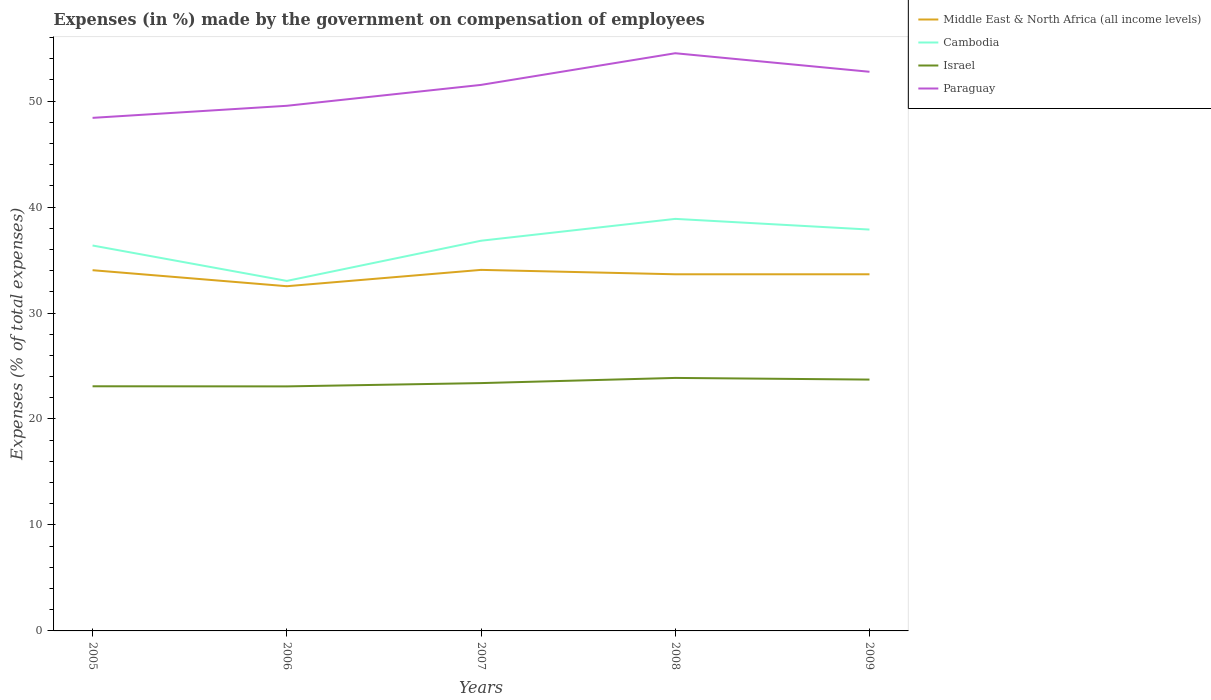Does the line corresponding to Israel intersect with the line corresponding to Middle East & North Africa (all income levels)?
Provide a short and direct response. No. Across all years, what is the maximum percentage of expenses made by the government on compensation of employees in Israel?
Offer a terse response. 23.08. In which year was the percentage of expenses made by the government on compensation of employees in Paraguay maximum?
Offer a very short reply. 2005. What is the total percentage of expenses made by the government on compensation of employees in Israel in the graph?
Offer a terse response. -0.49. What is the difference between the highest and the second highest percentage of expenses made by the government on compensation of employees in Middle East & North Africa (all income levels)?
Your answer should be compact. 1.54. What is the difference between the highest and the lowest percentage of expenses made by the government on compensation of employees in Middle East & North Africa (all income levels)?
Your answer should be very brief. 4. Is the percentage of expenses made by the government on compensation of employees in Cambodia strictly greater than the percentage of expenses made by the government on compensation of employees in Israel over the years?
Make the answer very short. No. How many lines are there?
Make the answer very short. 4. How many years are there in the graph?
Provide a short and direct response. 5. Are the values on the major ticks of Y-axis written in scientific E-notation?
Ensure brevity in your answer.  No. Does the graph contain grids?
Your answer should be very brief. No. Where does the legend appear in the graph?
Offer a terse response. Top right. How are the legend labels stacked?
Make the answer very short. Vertical. What is the title of the graph?
Offer a terse response. Expenses (in %) made by the government on compensation of employees. Does "Cote d'Ivoire" appear as one of the legend labels in the graph?
Provide a succinct answer. No. What is the label or title of the Y-axis?
Your answer should be very brief. Expenses (% of total expenses). What is the Expenses (% of total expenses) in Middle East & North Africa (all income levels) in 2005?
Give a very brief answer. 34.04. What is the Expenses (% of total expenses) in Cambodia in 2005?
Provide a short and direct response. 36.37. What is the Expenses (% of total expenses) of Israel in 2005?
Provide a succinct answer. 23.09. What is the Expenses (% of total expenses) in Paraguay in 2005?
Your answer should be compact. 48.42. What is the Expenses (% of total expenses) of Middle East & North Africa (all income levels) in 2006?
Provide a succinct answer. 32.53. What is the Expenses (% of total expenses) in Cambodia in 2006?
Your answer should be very brief. 33.03. What is the Expenses (% of total expenses) in Israel in 2006?
Give a very brief answer. 23.08. What is the Expenses (% of total expenses) of Paraguay in 2006?
Provide a succinct answer. 49.56. What is the Expenses (% of total expenses) of Middle East & North Africa (all income levels) in 2007?
Provide a short and direct response. 34.07. What is the Expenses (% of total expenses) of Cambodia in 2007?
Offer a very short reply. 36.82. What is the Expenses (% of total expenses) of Israel in 2007?
Give a very brief answer. 23.39. What is the Expenses (% of total expenses) in Paraguay in 2007?
Your response must be concise. 51.53. What is the Expenses (% of total expenses) of Middle East & North Africa (all income levels) in 2008?
Offer a very short reply. 33.65. What is the Expenses (% of total expenses) of Cambodia in 2008?
Provide a succinct answer. 38.88. What is the Expenses (% of total expenses) of Israel in 2008?
Ensure brevity in your answer.  23.87. What is the Expenses (% of total expenses) in Paraguay in 2008?
Your response must be concise. 54.52. What is the Expenses (% of total expenses) of Middle East & North Africa (all income levels) in 2009?
Offer a very short reply. 33.66. What is the Expenses (% of total expenses) in Cambodia in 2009?
Offer a terse response. 37.88. What is the Expenses (% of total expenses) in Israel in 2009?
Keep it short and to the point. 23.72. What is the Expenses (% of total expenses) of Paraguay in 2009?
Offer a very short reply. 52.77. Across all years, what is the maximum Expenses (% of total expenses) in Middle East & North Africa (all income levels)?
Make the answer very short. 34.07. Across all years, what is the maximum Expenses (% of total expenses) in Cambodia?
Ensure brevity in your answer.  38.88. Across all years, what is the maximum Expenses (% of total expenses) in Israel?
Offer a very short reply. 23.87. Across all years, what is the maximum Expenses (% of total expenses) in Paraguay?
Ensure brevity in your answer.  54.52. Across all years, what is the minimum Expenses (% of total expenses) of Middle East & North Africa (all income levels)?
Your answer should be very brief. 32.53. Across all years, what is the minimum Expenses (% of total expenses) in Cambodia?
Offer a very short reply. 33.03. Across all years, what is the minimum Expenses (% of total expenses) in Israel?
Your answer should be very brief. 23.08. Across all years, what is the minimum Expenses (% of total expenses) in Paraguay?
Give a very brief answer. 48.42. What is the total Expenses (% of total expenses) of Middle East & North Africa (all income levels) in the graph?
Your answer should be very brief. 167.95. What is the total Expenses (% of total expenses) in Cambodia in the graph?
Provide a succinct answer. 182.98. What is the total Expenses (% of total expenses) of Israel in the graph?
Your answer should be compact. 117.14. What is the total Expenses (% of total expenses) in Paraguay in the graph?
Your answer should be compact. 256.78. What is the difference between the Expenses (% of total expenses) in Middle East & North Africa (all income levels) in 2005 and that in 2006?
Make the answer very short. 1.51. What is the difference between the Expenses (% of total expenses) in Cambodia in 2005 and that in 2006?
Offer a very short reply. 3.34. What is the difference between the Expenses (% of total expenses) of Israel in 2005 and that in 2006?
Your answer should be compact. 0.01. What is the difference between the Expenses (% of total expenses) of Paraguay in 2005 and that in 2006?
Your response must be concise. -1.14. What is the difference between the Expenses (% of total expenses) of Middle East & North Africa (all income levels) in 2005 and that in 2007?
Offer a terse response. -0.03. What is the difference between the Expenses (% of total expenses) of Cambodia in 2005 and that in 2007?
Provide a succinct answer. -0.45. What is the difference between the Expenses (% of total expenses) in Israel in 2005 and that in 2007?
Provide a succinct answer. -0.3. What is the difference between the Expenses (% of total expenses) of Paraguay in 2005 and that in 2007?
Provide a succinct answer. -3.11. What is the difference between the Expenses (% of total expenses) of Middle East & North Africa (all income levels) in 2005 and that in 2008?
Keep it short and to the point. 0.39. What is the difference between the Expenses (% of total expenses) in Cambodia in 2005 and that in 2008?
Make the answer very short. -2.51. What is the difference between the Expenses (% of total expenses) of Israel in 2005 and that in 2008?
Your answer should be very brief. -0.79. What is the difference between the Expenses (% of total expenses) in Paraguay in 2005 and that in 2008?
Offer a terse response. -6.1. What is the difference between the Expenses (% of total expenses) of Middle East & North Africa (all income levels) in 2005 and that in 2009?
Your response must be concise. 0.39. What is the difference between the Expenses (% of total expenses) in Cambodia in 2005 and that in 2009?
Make the answer very short. -1.5. What is the difference between the Expenses (% of total expenses) in Israel in 2005 and that in 2009?
Keep it short and to the point. -0.63. What is the difference between the Expenses (% of total expenses) of Paraguay in 2005 and that in 2009?
Your answer should be compact. -4.35. What is the difference between the Expenses (% of total expenses) in Middle East & North Africa (all income levels) in 2006 and that in 2007?
Keep it short and to the point. -1.54. What is the difference between the Expenses (% of total expenses) in Cambodia in 2006 and that in 2007?
Your answer should be very brief. -3.79. What is the difference between the Expenses (% of total expenses) of Israel in 2006 and that in 2007?
Offer a terse response. -0.31. What is the difference between the Expenses (% of total expenses) in Paraguay in 2006 and that in 2007?
Your answer should be compact. -1.97. What is the difference between the Expenses (% of total expenses) of Middle East & North Africa (all income levels) in 2006 and that in 2008?
Offer a terse response. -1.13. What is the difference between the Expenses (% of total expenses) in Cambodia in 2006 and that in 2008?
Provide a succinct answer. -5.85. What is the difference between the Expenses (% of total expenses) in Israel in 2006 and that in 2008?
Make the answer very short. -0.8. What is the difference between the Expenses (% of total expenses) of Paraguay in 2006 and that in 2008?
Keep it short and to the point. -4.96. What is the difference between the Expenses (% of total expenses) in Middle East & North Africa (all income levels) in 2006 and that in 2009?
Offer a terse response. -1.13. What is the difference between the Expenses (% of total expenses) in Cambodia in 2006 and that in 2009?
Provide a succinct answer. -4.85. What is the difference between the Expenses (% of total expenses) in Israel in 2006 and that in 2009?
Ensure brevity in your answer.  -0.64. What is the difference between the Expenses (% of total expenses) in Paraguay in 2006 and that in 2009?
Provide a succinct answer. -3.21. What is the difference between the Expenses (% of total expenses) in Middle East & North Africa (all income levels) in 2007 and that in 2008?
Provide a succinct answer. 0.42. What is the difference between the Expenses (% of total expenses) of Cambodia in 2007 and that in 2008?
Give a very brief answer. -2.06. What is the difference between the Expenses (% of total expenses) in Israel in 2007 and that in 2008?
Provide a succinct answer. -0.49. What is the difference between the Expenses (% of total expenses) of Paraguay in 2007 and that in 2008?
Give a very brief answer. -2.99. What is the difference between the Expenses (% of total expenses) of Middle East & North Africa (all income levels) in 2007 and that in 2009?
Your answer should be very brief. 0.42. What is the difference between the Expenses (% of total expenses) of Cambodia in 2007 and that in 2009?
Offer a very short reply. -1.05. What is the difference between the Expenses (% of total expenses) of Israel in 2007 and that in 2009?
Your answer should be compact. -0.33. What is the difference between the Expenses (% of total expenses) of Paraguay in 2007 and that in 2009?
Ensure brevity in your answer.  -1.24. What is the difference between the Expenses (% of total expenses) in Middle East & North Africa (all income levels) in 2008 and that in 2009?
Your answer should be compact. -0. What is the difference between the Expenses (% of total expenses) of Cambodia in 2008 and that in 2009?
Your answer should be compact. 1.01. What is the difference between the Expenses (% of total expenses) of Israel in 2008 and that in 2009?
Keep it short and to the point. 0.16. What is the difference between the Expenses (% of total expenses) in Middle East & North Africa (all income levels) in 2005 and the Expenses (% of total expenses) in Cambodia in 2006?
Ensure brevity in your answer.  1.01. What is the difference between the Expenses (% of total expenses) of Middle East & North Africa (all income levels) in 2005 and the Expenses (% of total expenses) of Israel in 2006?
Your response must be concise. 10.96. What is the difference between the Expenses (% of total expenses) of Middle East & North Africa (all income levels) in 2005 and the Expenses (% of total expenses) of Paraguay in 2006?
Offer a terse response. -15.52. What is the difference between the Expenses (% of total expenses) in Cambodia in 2005 and the Expenses (% of total expenses) in Israel in 2006?
Make the answer very short. 13.29. What is the difference between the Expenses (% of total expenses) of Cambodia in 2005 and the Expenses (% of total expenses) of Paraguay in 2006?
Offer a terse response. -13.18. What is the difference between the Expenses (% of total expenses) in Israel in 2005 and the Expenses (% of total expenses) in Paraguay in 2006?
Your answer should be compact. -26.47. What is the difference between the Expenses (% of total expenses) in Middle East & North Africa (all income levels) in 2005 and the Expenses (% of total expenses) in Cambodia in 2007?
Give a very brief answer. -2.78. What is the difference between the Expenses (% of total expenses) in Middle East & North Africa (all income levels) in 2005 and the Expenses (% of total expenses) in Israel in 2007?
Offer a very short reply. 10.65. What is the difference between the Expenses (% of total expenses) of Middle East & North Africa (all income levels) in 2005 and the Expenses (% of total expenses) of Paraguay in 2007?
Give a very brief answer. -17.49. What is the difference between the Expenses (% of total expenses) in Cambodia in 2005 and the Expenses (% of total expenses) in Israel in 2007?
Ensure brevity in your answer.  12.98. What is the difference between the Expenses (% of total expenses) of Cambodia in 2005 and the Expenses (% of total expenses) of Paraguay in 2007?
Your answer should be very brief. -15.16. What is the difference between the Expenses (% of total expenses) in Israel in 2005 and the Expenses (% of total expenses) in Paraguay in 2007?
Keep it short and to the point. -28.44. What is the difference between the Expenses (% of total expenses) in Middle East & North Africa (all income levels) in 2005 and the Expenses (% of total expenses) in Cambodia in 2008?
Ensure brevity in your answer.  -4.84. What is the difference between the Expenses (% of total expenses) of Middle East & North Africa (all income levels) in 2005 and the Expenses (% of total expenses) of Israel in 2008?
Ensure brevity in your answer.  10.17. What is the difference between the Expenses (% of total expenses) in Middle East & North Africa (all income levels) in 2005 and the Expenses (% of total expenses) in Paraguay in 2008?
Your answer should be compact. -20.48. What is the difference between the Expenses (% of total expenses) in Cambodia in 2005 and the Expenses (% of total expenses) in Israel in 2008?
Ensure brevity in your answer.  12.5. What is the difference between the Expenses (% of total expenses) of Cambodia in 2005 and the Expenses (% of total expenses) of Paraguay in 2008?
Offer a very short reply. -18.14. What is the difference between the Expenses (% of total expenses) in Israel in 2005 and the Expenses (% of total expenses) in Paraguay in 2008?
Provide a succinct answer. -31.43. What is the difference between the Expenses (% of total expenses) of Middle East & North Africa (all income levels) in 2005 and the Expenses (% of total expenses) of Cambodia in 2009?
Your response must be concise. -3.84. What is the difference between the Expenses (% of total expenses) of Middle East & North Africa (all income levels) in 2005 and the Expenses (% of total expenses) of Israel in 2009?
Your answer should be compact. 10.32. What is the difference between the Expenses (% of total expenses) of Middle East & North Africa (all income levels) in 2005 and the Expenses (% of total expenses) of Paraguay in 2009?
Make the answer very short. -18.72. What is the difference between the Expenses (% of total expenses) in Cambodia in 2005 and the Expenses (% of total expenses) in Israel in 2009?
Offer a terse response. 12.65. What is the difference between the Expenses (% of total expenses) of Cambodia in 2005 and the Expenses (% of total expenses) of Paraguay in 2009?
Offer a very short reply. -16.39. What is the difference between the Expenses (% of total expenses) in Israel in 2005 and the Expenses (% of total expenses) in Paraguay in 2009?
Your answer should be compact. -29.68. What is the difference between the Expenses (% of total expenses) in Middle East & North Africa (all income levels) in 2006 and the Expenses (% of total expenses) in Cambodia in 2007?
Offer a terse response. -4.29. What is the difference between the Expenses (% of total expenses) in Middle East & North Africa (all income levels) in 2006 and the Expenses (% of total expenses) in Israel in 2007?
Your answer should be very brief. 9.14. What is the difference between the Expenses (% of total expenses) of Middle East & North Africa (all income levels) in 2006 and the Expenses (% of total expenses) of Paraguay in 2007?
Your answer should be very brief. -19. What is the difference between the Expenses (% of total expenses) of Cambodia in 2006 and the Expenses (% of total expenses) of Israel in 2007?
Provide a short and direct response. 9.64. What is the difference between the Expenses (% of total expenses) of Cambodia in 2006 and the Expenses (% of total expenses) of Paraguay in 2007?
Your answer should be very brief. -18.5. What is the difference between the Expenses (% of total expenses) in Israel in 2006 and the Expenses (% of total expenses) in Paraguay in 2007?
Make the answer very short. -28.45. What is the difference between the Expenses (% of total expenses) of Middle East & North Africa (all income levels) in 2006 and the Expenses (% of total expenses) of Cambodia in 2008?
Your answer should be very brief. -6.35. What is the difference between the Expenses (% of total expenses) of Middle East & North Africa (all income levels) in 2006 and the Expenses (% of total expenses) of Israel in 2008?
Offer a very short reply. 8.65. What is the difference between the Expenses (% of total expenses) in Middle East & North Africa (all income levels) in 2006 and the Expenses (% of total expenses) in Paraguay in 2008?
Make the answer very short. -21.99. What is the difference between the Expenses (% of total expenses) of Cambodia in 2006 and the Expenses (% of total expenses) of Israel in 2008?
Offer a very short reply. 9.15. What is the difference between the Expenses (% of total expenses) of Cambodia in 2006 and the Expenses (% of total expenses) of Paraguay in 2008?
Make the answer very short. -21.49. What is the difference between the Expenses (% of total expenses) in Israel in 2006 and the Expenses (% of total expenses) in Paraguay in 2008?
Your answer should be compact. -31.44. What is the difference between the Expenses (% of total expenses) of Middle East & North Africa (all income levels) in 2006 and the Expenses (% of total expenses) of Cambodia in 2009?
Your answer should be very brief. -5.35. What is the difference between the Expenses (% of total expenses) in Middle East & North Africa (all income levels) in 2006 and the Expenses (% of total expenses) in Israel in 2009?
Make the answer very short. 8.81. What is the difference between the Expenses (% of total expenses) in Middle East & North Africa (all income levels) in 2006 and the Expenses (% of total expenses) in Paraguay in 2009?
Provide a short and direct response. -20.24. What is the difference between the Expenses (% of total expenses) of Cambodia in 2006 and the Expenses (% of total expenses) of Israel in 2009?
Provide a succinct answer. 9.31. What is the difference between the Expenses (% of total expenses) in Cambodia in 2006 and the Expenses (% of total expenses) in Paraguay in 2009?
Ensure brevity in your answer.  -19.74. What is the difference between the Expenses (% of total expenses) of Israel in 2006 and the Expenses (% of total expenses) of Paraguay in 2009?
Your answer should be compact. -29.69. What is the difference between the Expenses (% of total expenses) of Middle East & North Africa (all income levels) in 2007 and the Expenses (% of total expenses) of Cambodia in 2008?
Give a very brief answer. -4.81. What is the difference between the Expenses (% of total expenses) of Middle East & North Africa (all income levels) in 2007 and the Expenses (% of total expenses) of Israel in 2008?
Your response must be concise. 10.2. What is the difference between the Expenses (% of total expenses) of Middle East & North Africa (all income levels) in 2007 and the Expenses (% of total expenses) of Paraguay in 2008?
Offer a terse response. -20.44. What is the difference between the Expenses (% of total expenses) of Cambodia in 2007 and the Expenses (% of total expenses) of Israel in 2008?
Offer a very short reply. 12.95. What is the difference between the Expenses (% of total expenses) in Cambodia in 2007 and the Expenses (% of total expenses) in Paraguay in 2008?
Make the answer very short. -17.69. What is the difference between the Expenses (% of total expenses) in Israel in 2007 and the Expenses (% of total expenses) in Paraguay in 2008?
Make the answer very short. -31.13. What is the difference between the Expenses (% of total expenses) of Middle East & North Africa (all income levels) in 2007 and the Expenses (% of total expenses) of Cambodia in 2009?
Give a very brief answer. -3.8. What is the difference between the Expenses (% of total expenses) of Middle East & North Africa (all income levels) in 2007 and the Expenses (% of total expenses) of Israel in 2009?
Make the answer very short. 10.35. What is the difference between the Expenses (% of total expenses) of Middle East & North Africa (all income levels) in 2007 and the Expenses (% of total expenses) of Paraguay in 2009?
Your answer should be compact. -18.69. What is the difference between the Expenses (% of total expenses) in Cambodia in 2007 and the Expenses (% of total expenses) in Israel in 2009?
Offer a terse response. 13.1. What is the difference between the Expenses (% of total expenses) of Cambodia in 2007 and the Expenses (% of total expenses) of Paraguay in 2009?
Your response must be concise. -15.94. What is the difference between the Expenses (% of total expenses) of Israel in 2007 and the Expenses (% of total expenses) of Paraguay in 2009?
Your answer should be compact. -29.38. What is the difference between the Expenses (% of total expenses) in Middle East & North Africa (all income levels) in 2008 and the Expenses (% of total expenses) in Cambodia in 2009?
Make the answer very short. -4.22. What is the difference between the Expenses (% of total expenses) of Middle East & North Africa (all income levels) in 2008 and the Expenses (% of total expenses) of Israel in 2009?
Give a very brief answer. 9.94. What is the difference between the Expenses (% of total expenses) in Middle East & North Africa (all income levels) in 2008 and the Expenses (% of total expenses) in Paraguay in 2009?
Make the answer very short. -19.11. What is the difference between the Expenses (% of total expenses) of Cambodia in 2008 and the Expenses (% of total expenses) of Israel in 2009?
Your response must be concise. 15.16. What is the difference between the Expenses (% of total expenses) in Cambodia in 2008 and the Expenses (% of total expenses) in Paraguay in 2009?
Ensure brevity in your answer.  -13.88. What is the difference between the Expenses (% of total expenses) of Israel in 2008 and the Expenses (% of total expenses) of Paraguay in 2009?
Ensure brevity in your answer.  -28.89. What is the average Expenses (% of total expenses) of Middle East & North Africa (all income levels) per year?
Provide a succinct answer. 33.59. What is the average Expenses (% of total expenses) of Cambodia per year?
Offer a terse response. 36.6. What is the average Expenses (% of total expenses) of Israel per year?
Give a very brief answer. 23.43. What is the average Expenses (% of total expenses) in Paraguay per year?
Your answer should be very brief. 51.36. In the year 2005, what is the difference between the Expenses (% of total expenses) of Middle East & North Africa (all income levels) and Expenses (% of total expenses) of Cambodia?
Give a very brief answer. -2.33. In the year 2005, what is the difference between the Expenses (% of total expenses) of Middle East & North Africa (all income levels) and Expenses (% of total expenses) of Israel?
Make the answer very short. 10.95. In the year 2005, what is the difference between the Expenses (% of total expenses) of Middle East & North Africa (all income levels) and Expenses (% of total expenses) of Paraguay?
Provide a short and direct response. -14.38. In the year 2005, what is the difference between the Expenses (% of total expenses) of Cambodia and Expenses (% of total expenses) of Israel?
Offer a very short reply. 13.29. In the year 2005, what is the difference between the Expenses (% of total expenses) of Cambodia and Expenses (% of total expenses) of Paraguay?
Your response must be concise. -12.05. In the year 2005, what is the difference between the Expenses (% of total expenses) of Israel and Expenses (% of total expenses) of Paraguay?
Provide a short and direct response. -25.33. In the year 2006, what is the difference between the Expenses (% of total expenses) of Middle East & North Africa (all income levels) and Expenses (% of total expenses) of Cambodia?
Provide a succinct answer. -0.5. In the year 2006, what is the difference between the Expenses (% of total expenses) of Middle East & North Africa (all income levels) and Expenses (% of total expenses) of Israel?
Offer a very short reply. 9.45. In the year 2006, what is the difference between the Expenses (% of total expenses) of Middle East & North Africa (all income levels) and Expenses (% of total expenses) of Paraguay?
Provide a short and direct response. -17.03. In the year 2006, what is the difference between the Expenses (% of total expenses) of Cambodia and Expenses (% of total expenses) of Israel?
Provide a succinct answer. 9.95. In the year 2006, what is the difference between the Expenses (% of total expenses) of Cambodia and Expenses (% of total expenses) of Paraguay?
Provide a succinct answer. -16.53. In the year 2006, what is the difference between the Expenses (% of total expenses) in Israel and Expenses (% of total expenses) in Paraguay?
Ensure brevity in your answer.  -26.48. In the year 2007, what is the difference between the Expenses (% of total expenses) of Middle East & North Africa (all income levels) and Expenses (% of total expenses) of Cambodia?
Provide a short and direct response. -2.75. In the year 2007, what is the difference between the Expenses (% of total expenses) in Middle East & North Africa (all income levels) and Expenses (% of total expenses) in Israel?
Keep it short and to the point. 10.68. In the year 2007, what is the difference between the Expenses (% of total expenses) of Middle East & North Africa (all income levels) and Expenses (% of total expenses) of Paraguay?
Offer a terse response. -17.46. In the year 2007, what is the difference between the Expenses (% of total expenses) in Cambodia and Expenses (% of total expenses) in Israel?
Offer a terse response. 13.43. In the year 2007, what is the difference between the Expenses (% of total expenses) of Cambodia and Expenses (% of total expenses) of Paraguay?
Provide a short and direct response. -14.71. In the year 2007, what is the difference between the Expenses (% of total expenses) of Israel and Expenses (% of total expenses) of Paraguay?
Ensure brevity in your answer.  -28.14. In the year 2008, what is the difference between the Expenses (% of total expenses) in Middle East & North Africa (all income levels) and Expenses (% of total expenses) in Cambodia?
Provide a short and direct response. -5.23. In the year 2008, what is the difference between the Expenses (% of total expenses) in Middle East & North Africa (all income levels) and Expenses (% of total expenses) in Israel?
Your answer should be compact. 9.78. In the year 2008, what is the difference between the Expenses (% of total expenses) of Middle East & North Africa (all income levels) and Expenses (% of total expenses) of Paraguay?
Give a very brief answer. -20.86. In the year 2008, what is the difference between the Expenses (% of total expenses) of Cambodia and Expenses (% of total expenses) of Israel?
Give a very brief answer. 15.01. In the year 2008, what is the difference between the Expenses (% of total expenses) of Cambodia and Expenses (% of total expenses) of Paraguay?
Provide a succinct answer. -15.63. In the year 2008, what is the difference between the Expenses (% of total expenses) of Israel and Expenses (% of total expenses) of Paraguay?
Offer a very short reply. -30.64. In the year 2009, what is the difference between the Expenses (% of total expenses) of Middle East & North Africa (all income levels) and Expenses (% of total expenses) of Cambodia?
Provide a succinct answer. -4.22. In the year 2009, what is the difference between the Expenses (% of total expenses) in Middle East & North Africa (all income levels) and Expenses (% of total expenses) in Israel?
Provide a short and direct response. 9.94. In the year 2009, what is the difference between the Expenses (% of total expenses) in Middle East & North Africa (all income levels) and Expenses (% of total expenses) in Paraguay?
Your answer should be compact. -19.11. In the year 2009, what is the difference between the Expenses (% of total expenses) of Cambodia and Expenses (% of total expenses) of Israel?
Offer a terse response. 14.16. In the year 2009, what is the difference between the Expenses (% of total expenses) of Cambodia and Expenses (% of total expenses) of Paraguay?
Your answer should be very brief. -14.89. In the year 2009, what is the difference between the Expenses (% of total expenses) of Israel and Expenses (% of total expenses) of Paraguay?
Provide a succinct answer. -29.05. What is the ratio of the Expenses (% of total expenses) in Middle East & North Africa (all income levels) in 2005 to that in 2006?
Your answer should be compact. 1.05. What is the ratio of the Expenses (% of total expenses) of Cambodia in 2005 to that in 2006?
Ensure brevity in your answer.  1.1. What is the ratio of the Expenses (% of total expenses) of Israel in 2005 to that in 2006?
Your answer should be compact. 1. What is the ratio of the Expenses (% of total expenses) in Middle East & North Africa (all income levels) in 2005 to that in 2007?
Offer a terse response. 1. What is the ratio of the Expenses (% of total expenses) in Cambodia in 2005 to that in 2007?
Give a very brief answer. 0.99. What is the ratio of the Expenses (% of total expenses) of Israel in 2005 to that in 2007?
Make the answer very short. 0.99. What is the ratio of the Expenses (% of total expenses) of Paraguay in 2005 to that in 2007?
Make the answer very short. 0.94. What is the ratio of the Expenses (% of total expenses) in Middle East & North Africa (all income levels) in 2005 to that in 2008?
Offer a very short reply. 1.01. What is the ratio of the Expenses (% of total expenses) of Cambodia in 2005 to that in 2008?
Provide a succinct answer. 0.94. What is the ratio of the Expenses (% of total expenses) of Israel in 2005 to that in 2008?
Provide a succinct answer. 0.97. What is the ratio of the Expenses (% of total expenses) in Paraguay in 2005 to that in 2008?
Your response must be concise. 0.89. What is the ratio of the Expenses (% of total expenses) in Middle East & North Africa (all income levels) in 2005 to that in 2009?
Ensure brevity in your answer.  1.01. What is the ratio of the Expenses (% of total expenses) in Cambodia in 2005 to that in 2009?
Keep it short and to the point. 0.96. What is the ratio of the Expenses (% of total expenses) in Israel in 2005 to that in 2009?
Your answer should be compact. 0.97. What is the ratio of the Expenses (% of total expenses) in Paraguay in 2005 to that in 2009?
Your response must be concise. 0.92. What is the ratio of the Expenses (% of total expenses) of Middle East & North Africa (all income levels) in 2006 to that in 2007?
Provide a succinct answer. 0.95. What is the ratio of the Expenses (% of total expenses) of Cambodia in 2006 to that in 2007?
Provide a succinct answer. 0.9. What is the ratio of the Expenses (% of total expenses) in Israel in 2006 to that in 2007?
Your response must be concise. 0.99. What is the ratio of the Expenses (% of total expenses) in Paraguay in 2006 to that in 2007?
Provide a succinct answer. 0.96. What is the ratio of the Expenses (% of total expenses) of Middle East & North Africa (all income levels) in 2006 to that in 2008?
Provide a succinct answer. 0.97. What is the ratio of the Expenses (% of total expenses) in Cambodia in 2006 to that in 2008?
Make the answer very short. 0.85. What is the ratio of the Expenses (% of total expenses) of Israel in 2006 to that in 2008?
Make the answer very short. 0.97. What is the ratio of the Expenses (% of total expenses) in Paraguay in 2006 to that in 2008?
Your answer should be compact. 0.91. What is the ratio of the Expenses (% of total expenses) of Middle East & North Africa (all income levels) in 2006 to that in 2009?
Give a very brief answer. 0.97. What is the ratio of the Expenses (% of total expenses) of Cambodia in 2006 to that in 2009?
Your answer should be very brief. 0.87. What is the ratio of the Expenses (% of total expenses) of Israel in 2006 to that in 2009?
Offer a terse response. 0.97. What is the ratio of the Expenses (% of total expenses) in Paraguay in 2006 to that in 2009?
Make the answer very short. 0.94. What is the ratio of the Expenses (% of total expenses) of Middle East & North Africa (all income levels) in 2007 to that in 2008?
Make the answer very short. 1.01. What is the ratio of the Expenses (% of total expenses) in Cambodia in 2007 to that in 2008?
Provide a short and direct response. 0.95. What is the ratio of the Expenses (% of total expenses) in Israel in 2007 to that in 2008?
Offer a terse response. 0.98. What is the ratio of the Expenses (% of total expenses) in Paraguay in 2007 to that in 2008?
Offer a very short reply. 0.95. What is the ratio of the Expenses (% of total expenses) of Middle East & North Africa (all income levels) in 2007 to that in 2009?
Make the answer very short. 1.01. What is the ratio of the Expenses (% of total expenses) in Cambodia in 2007 to that in 2009?
Offer a terse response. 0.97. What is the ratio of the Expenses (% of total expenses) of Paraguay in 2007 to that in 2009?
Your response must be concise. 0.98. What is the ratio of the Expenses (% of total expenses) in Middle East & North Africa (all income levels) in 2008 to that in 2009?
Your answer should be compact. 1. What is the ratio of the Expenses (% of total expenses) in Cambodia in 2008 to that in 2009?
Ensure brevity in your answer.  1.03. What is the ratio of the Expenses (% of total expenses) of Israel in 2008 to that in 2009?
Your answer should be compact. 1.01. What is the ratio of the Expenses (% of total expenses) of Paraguay in 2008 to that in 2009?
Offer a terse response. 1.03. What is the difference between the highest and the second highest Expenses (% of total expenses) of Middle East & North Africa (all income levels)?
Make the answer very short. 0.03. What is the difference between the highest and the second highest Expenses (% of total expenses) of Cambodia?
Provide a short and direct response. 1.01. What is the difference between the highest and the second highest Expenses (% of total expenses) in Israel?
Offer a terse response. 0.16. What is the difference between the highest and the second highest Expenses (% of total expenses) of Paraguay?
Provide a succinct answer. 1.75. What is the difference between the highest and the lowest Expenses (% of total expenses) in Middle East & North Africa (all income levels)?
Keep it short and to the point. 1.54. What is the difference between the highest and the lowest Expenses (% of total expenses) in Cambodia?
Your answer should be compact. 5.85. What is the difference between the highest and the lowest Expenses (% of total expenses) of Israel?
Ensure brevity in your answer.  0.8. What is the difference between the highest and the lowest Expenses (% of total expenses) in Paraguay?
Provide a succinct answer. 6.1. 